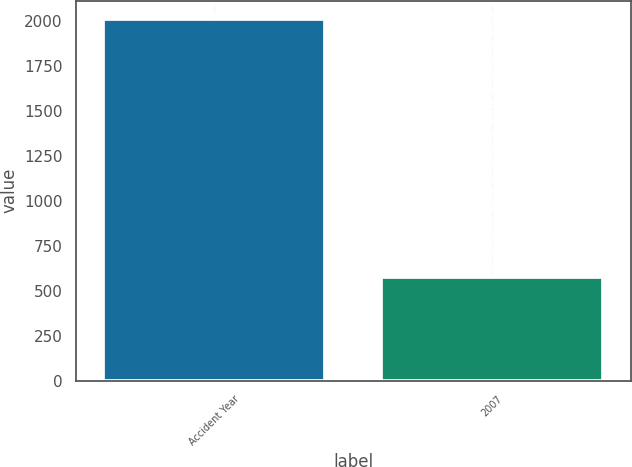<chart> <loc_0><loc_0><loc_500><loc_500><bar_chart><fcel>Accident Year<fcel>2007<nl><fcel>2012<fcel>575<nl></chart> 